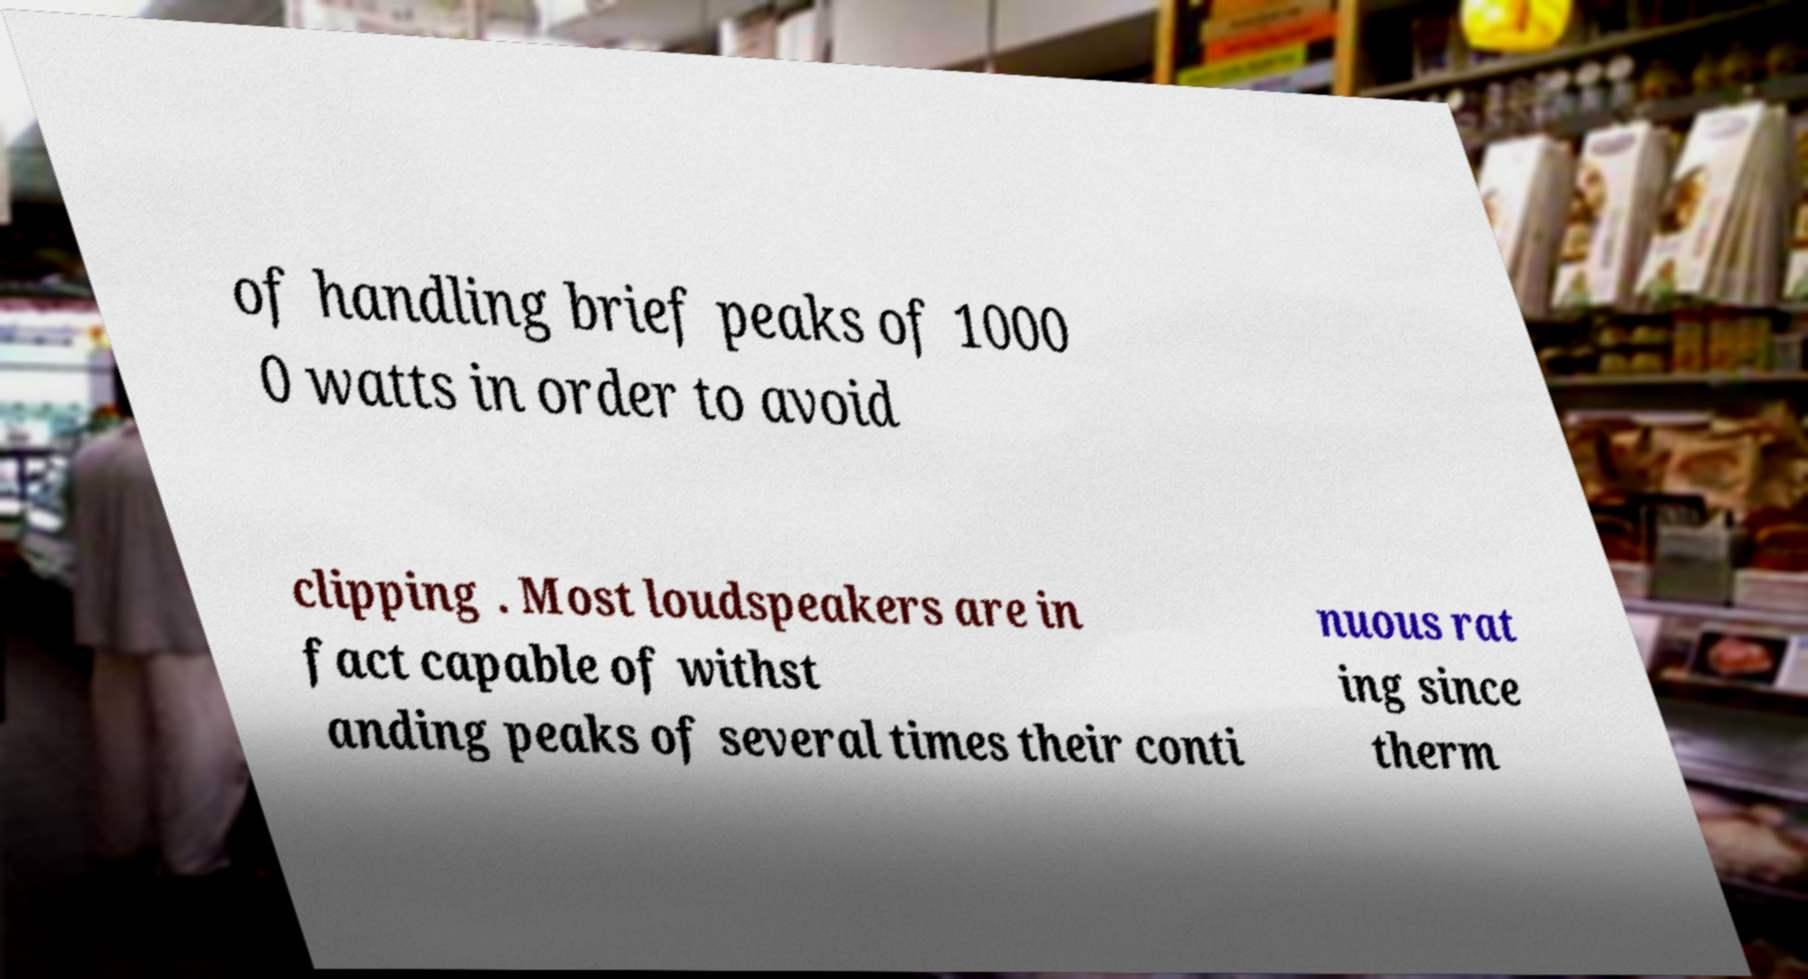I need the written content from this picture converted into text. Can you do that? of handling brief peaks of 1000 0 watts in order to avoid clipping . Most loudspeakers are in fact capable of withst anding peaks of several times their conti nuous rat ing since therm 